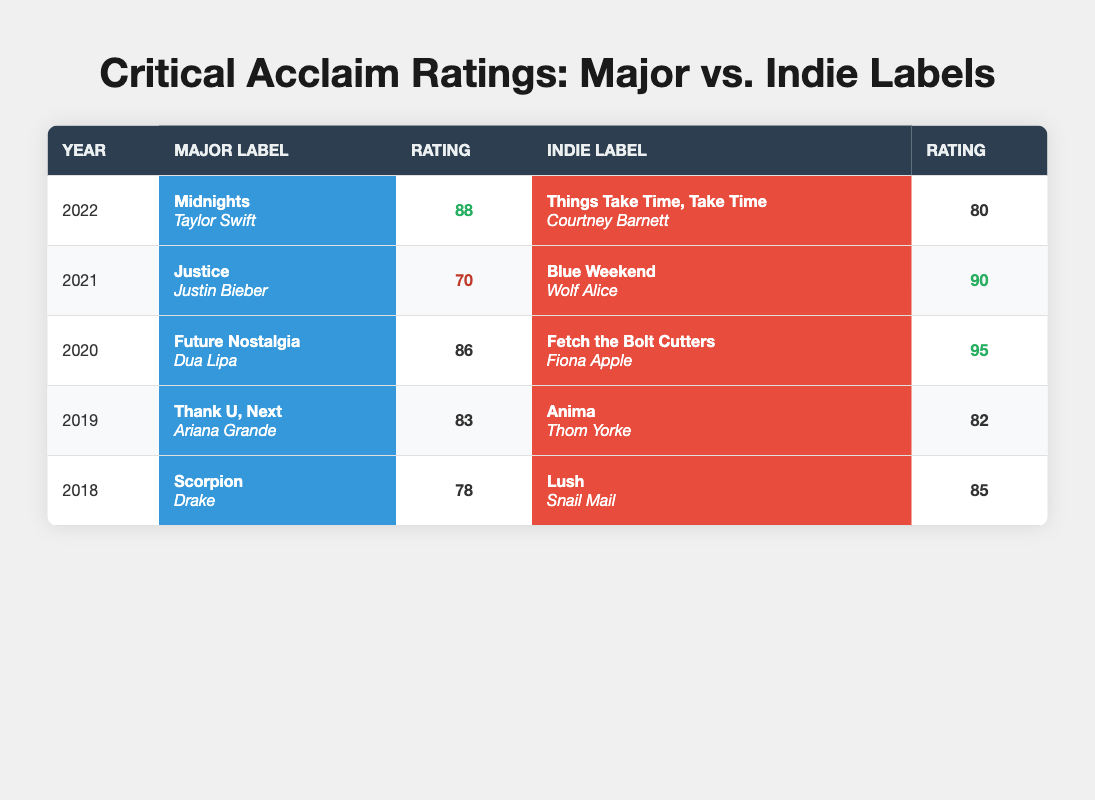What was the highest critical acclaim rating for a major label album? Examining the table, the major label album with the highest rating is "Midnights" by Taylor Swift in 2022, which has a rating of 88.
Answer: 88 Which indie album released in 2020 received the highest critical acclaim rating? The indie album "Fetch the Bolt Cutters" by Fiona Apple released in 2020 received the highest rating of 95.
Answer: 95 What is the overall average critical acclaim rating for major label albums from 2018 to 2022? Adding the ratings for the major albums (78 + 83 + 86 + 70 + 88) gives a total of 405. There are 5 albums, so the average is 405/5 = 81.
Answer: 81 Was there an indie album released in 2019 that received a higher rating than the major album released that same year? Yes, "Anima" by Thom Yorke released in 2019 received a rating of 82, which is higher than "Thank U, Next" by Ariana Grande's rating of 83.
Answer: Yes In which year did indie albums outperform major albums in critical acclaim ratings? In 2020 and 2021, indie albums ("Fetch the Bolt Cutters" with 95 and "Blue Weekend" with 90) had higher ratings than the major albums ("Future Nostalgia" with 86 and "Justice" with 70).
Answer: 2020 and 2021 What is the difference in ratings between the highest and lowest-rated major label albums? The highest major album rating is 88 (Taylor Swift's "Midnights") and the lowest is 70 (Justin Bieber's "Justice"). The difference is 88 - 70 = 18.
Answer: 18 Which label had more albums rated above 80 in the years mentioned? The indie label had 4 albums rated above 80 (ratings 85, 82, 95, and 90) while the major label had 3 albums above 80 (ratings 83, 86, and 88). Therefore, the indie label outperformed.
Answer: Indie How many years did a major label album receive a rating below 80? By reviewing the table, we see that out of five years, only one year (2021) had a major label album rated below 80 (70 for "Justice").
Answer: 1 What is the average critical acclaim rating for indie albums over the five-year span? Adding the indie ratings (85 + 82 + 95 + 90 + 80) totals 432. Dividing by 5 gives an average of 432/5 = 86.4.
Answer: 86.4 